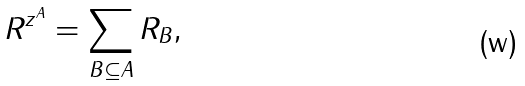Convert formula to latex. <formula><loc_0><loc_0><loc_500><loc_500>R ^ { z ^ { A } } = \sum _ { B \subseteq A } R _ { B } ,</formula> 